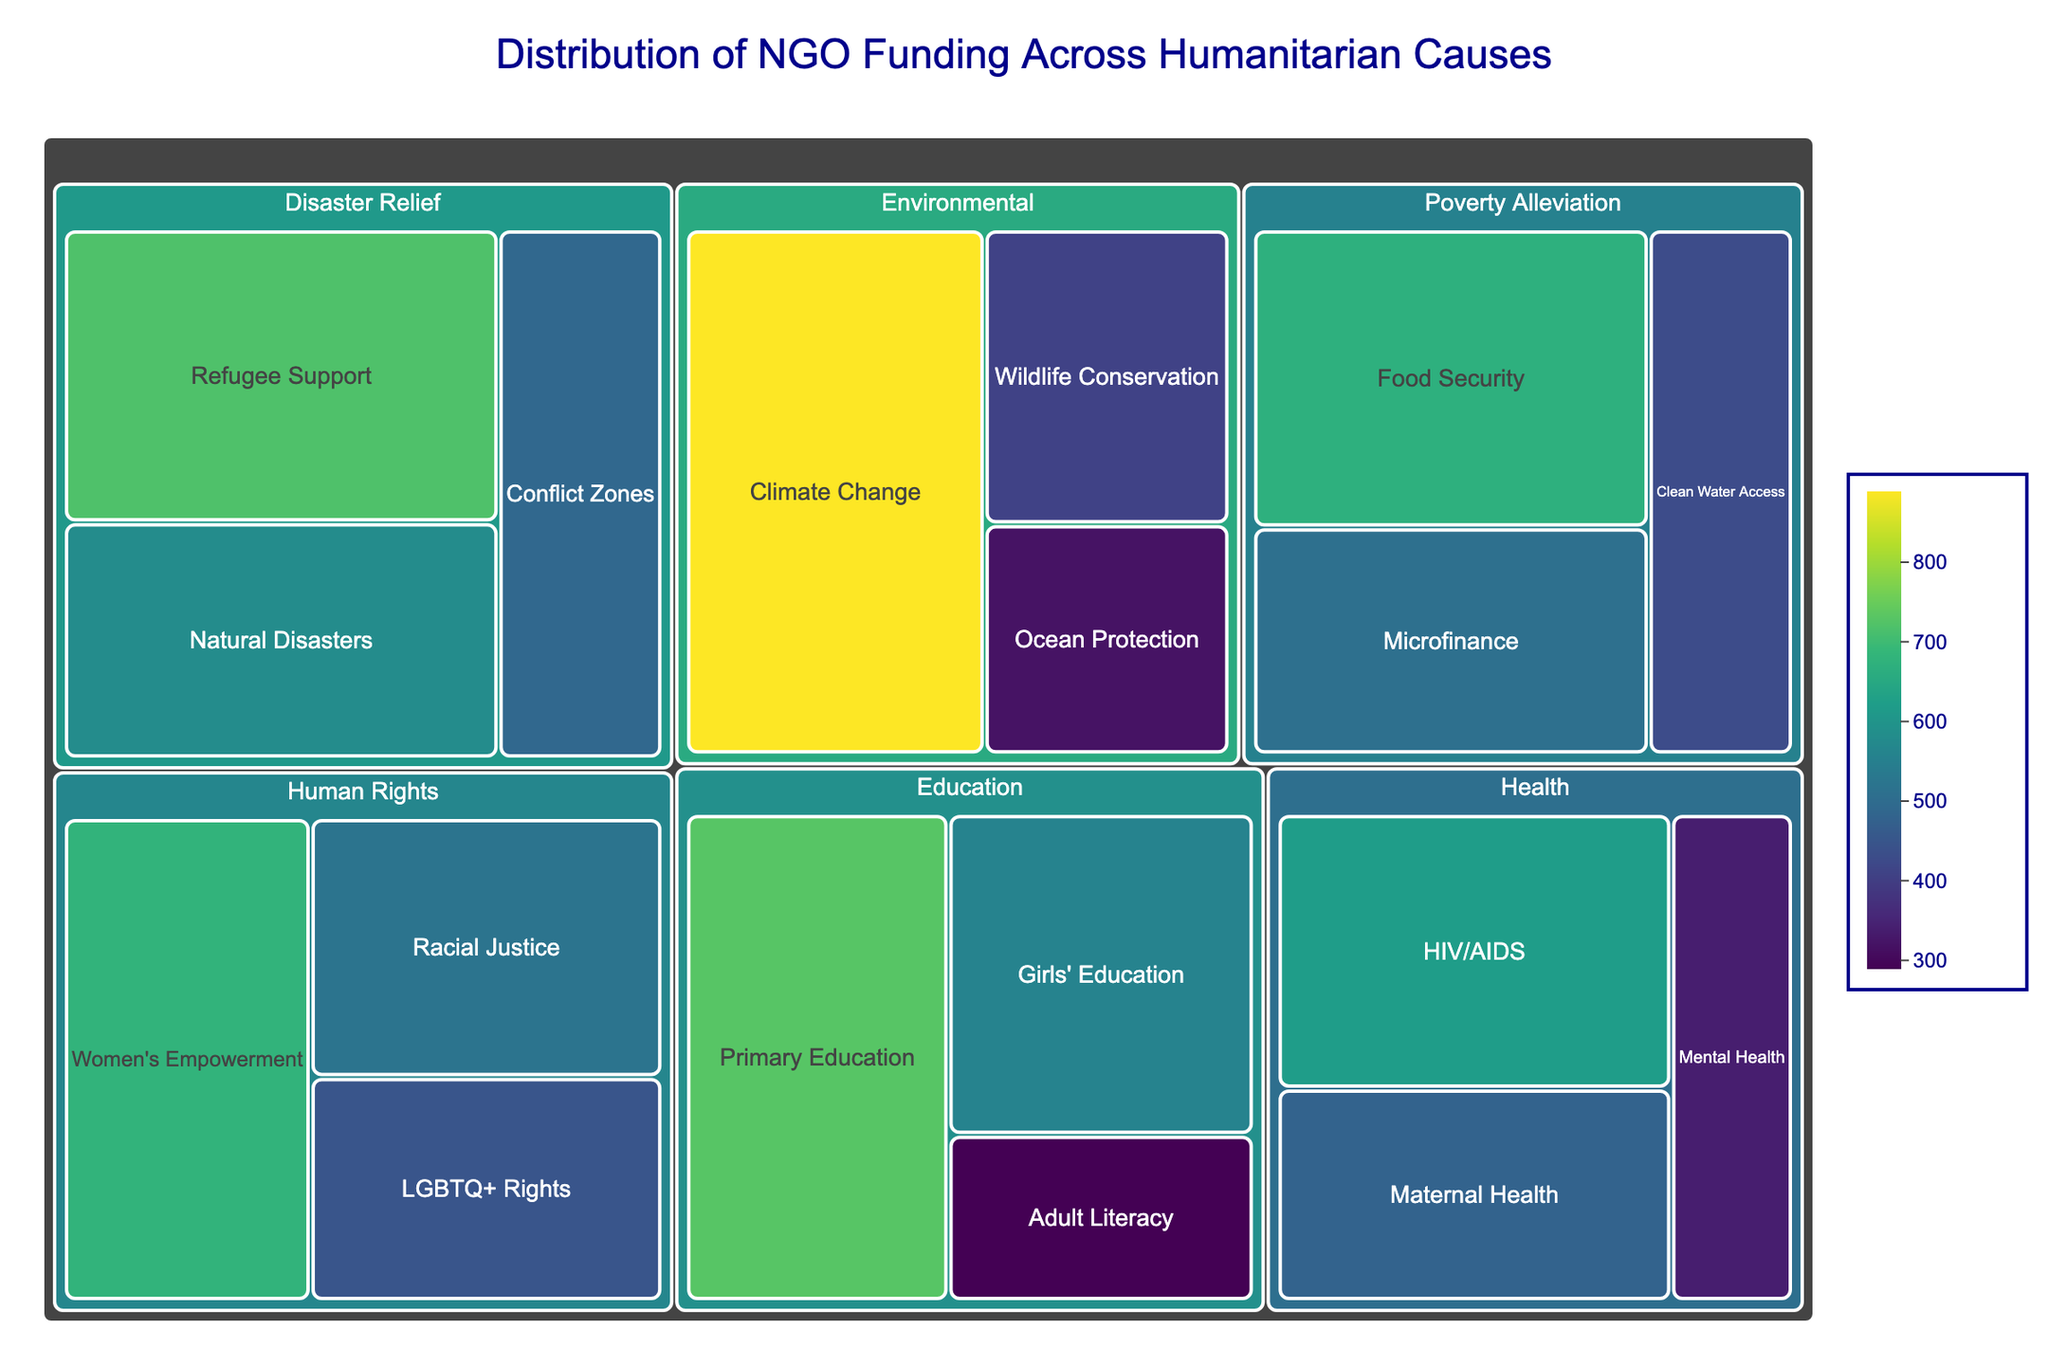What's the title of the figure? The title of the figure is usually found at the top of the visual representation, and it helps to understand the overall theme or content of the chart.
Answer: Distribution of NGO Funding Across Humanitarian Causes What subcategory in Health received the most funding? To answer this, look at the Health category and identify which subcategory has the largest tile.
Answer: HIV/AIDS Which category has the largest total funding? Add up the funding for all subcategories within each category and identify which sum is the largest. Environmental: 890 + 410 + 320 = 1620; Education: 730 + 560 + 290 = 1580; Health: 620 + 480 + 340 = 1440; Poverty Alleviation: 510 + 670 + 430 = 1610; Disaster Relief: 580 + 720 + 490 = 1790; Human Rights: 450 + 680 + 520 = 1650. The Disaster Relief category has the largest total funding.
Answer: Disaster Relief How much more funding did Climate Change receive compared to Ocean Protection? Find the tile for each subcategory within the Environmental category and subtract the funding for Ocean Protection from the funding for Climate Change. 890 (Climate Change) - 320 (Ocean Protection) = 570.
Answer: 570 million USD Which has higher funding: Microfinance or Clean Water Access? Compare the size of the tiles for Microfinance and Clean Water Access within the Poverty Alleviation category to see which is larger.
Answer: Microfinance What is the total funding received by Disaster Relief causes? Add the funding of all subcategories under the Disaster Relief category. 580 (Natural Disasters) + 720 (Refugee Support) + 490 (Conflict Zones) = 1790.
Answer: 1790 million USD Does Girls' Education receive more funding than Women's Empowerment? Compare the tiles for Girls' Education under Education and Women's Empowerment under Human Rights. Girls' Education: 560; Women's Empowerment: 680.
Answer: No What is the difference in funding between Racial Justice and Mental Health? Subtract the funding for Mental Health from the funding for Racial Justice. 520 (Racial Justice) - 340 (Mental Health) = 180.
Answer: 180 million USD What subcategory received the least funding under Education? Look at the Education category and identify the smallest tile, which represents the subcategory with the least funding.
Answer: Adult Literacy Which has a greater funding allocation: Wildlife Conservation or Food Security? Compare the tiles for Wildlife Conservation under Environmental and Food Security under Poverty Alleviation.
Answer: Food Security 